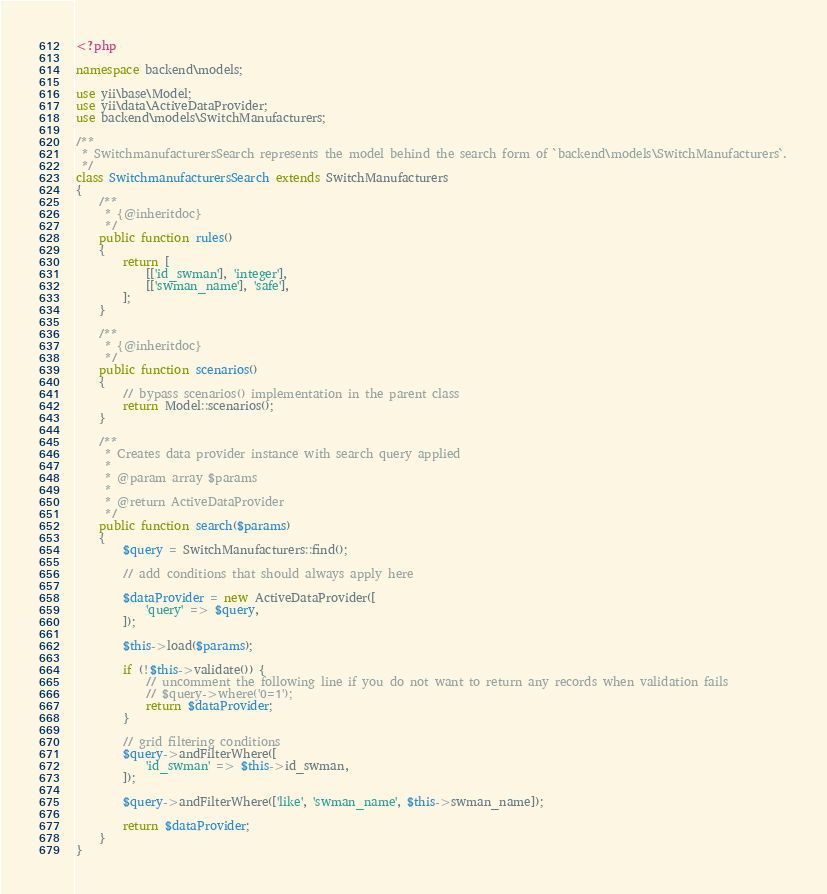Convert code to text. <code><loc_0><loc_0><loc_500><loc_500><_PHP_><?php

namespace backend\models;

use yii\base\Model;
use yii\data\ActiveDataProvider;
use backend\models\SwitchManufacturers;

/**
 * SwitchmanufacturersSearch represents the model behind the search form of `backend\models\SwitchManufacturers`.
 */
class SwitchmanufacturersSearch extends SwitchManufacturers
{
    /**
     * {@inheritdoc}
     */
    public function rules()
    {
        return [
            [['id_swman'], 'integer'],
            [['swman_name'], 'safe'],
        ];
    }

    /**
     * {@inheritdoc}
     */
    public function scenarios()
    {
        // bypass scenarios() implementation in the parent class
        return Model::scenarios();
    }

    /**
     * Creates data provider instance with search query applied
     *
     * @param array $params
     *
     * @return ActiveDataProvider
     */
    public function search($params)
    {
        $query = SwitchManufacturers::find();

        // add conditions that should always apply here

        $dataProvider = new ActiveDataProvider([
            'query' => $query,
        ]);

        $this->load($params);

        if (!$this->validate()) {
            // uncomment the following line if you do not want to return any records when validation fails
            // $query->where('0=1');
            return $dataProvider;
        }

        // grid filtering conditions
        $query->andFilterWhere([
            'id_swman' => $this->id_swman,
        ]);

        $query->andFilterWhere(['like', 'swman_name', $this->swman_name]);

        return $dataProvider;
    }
}
</code> 